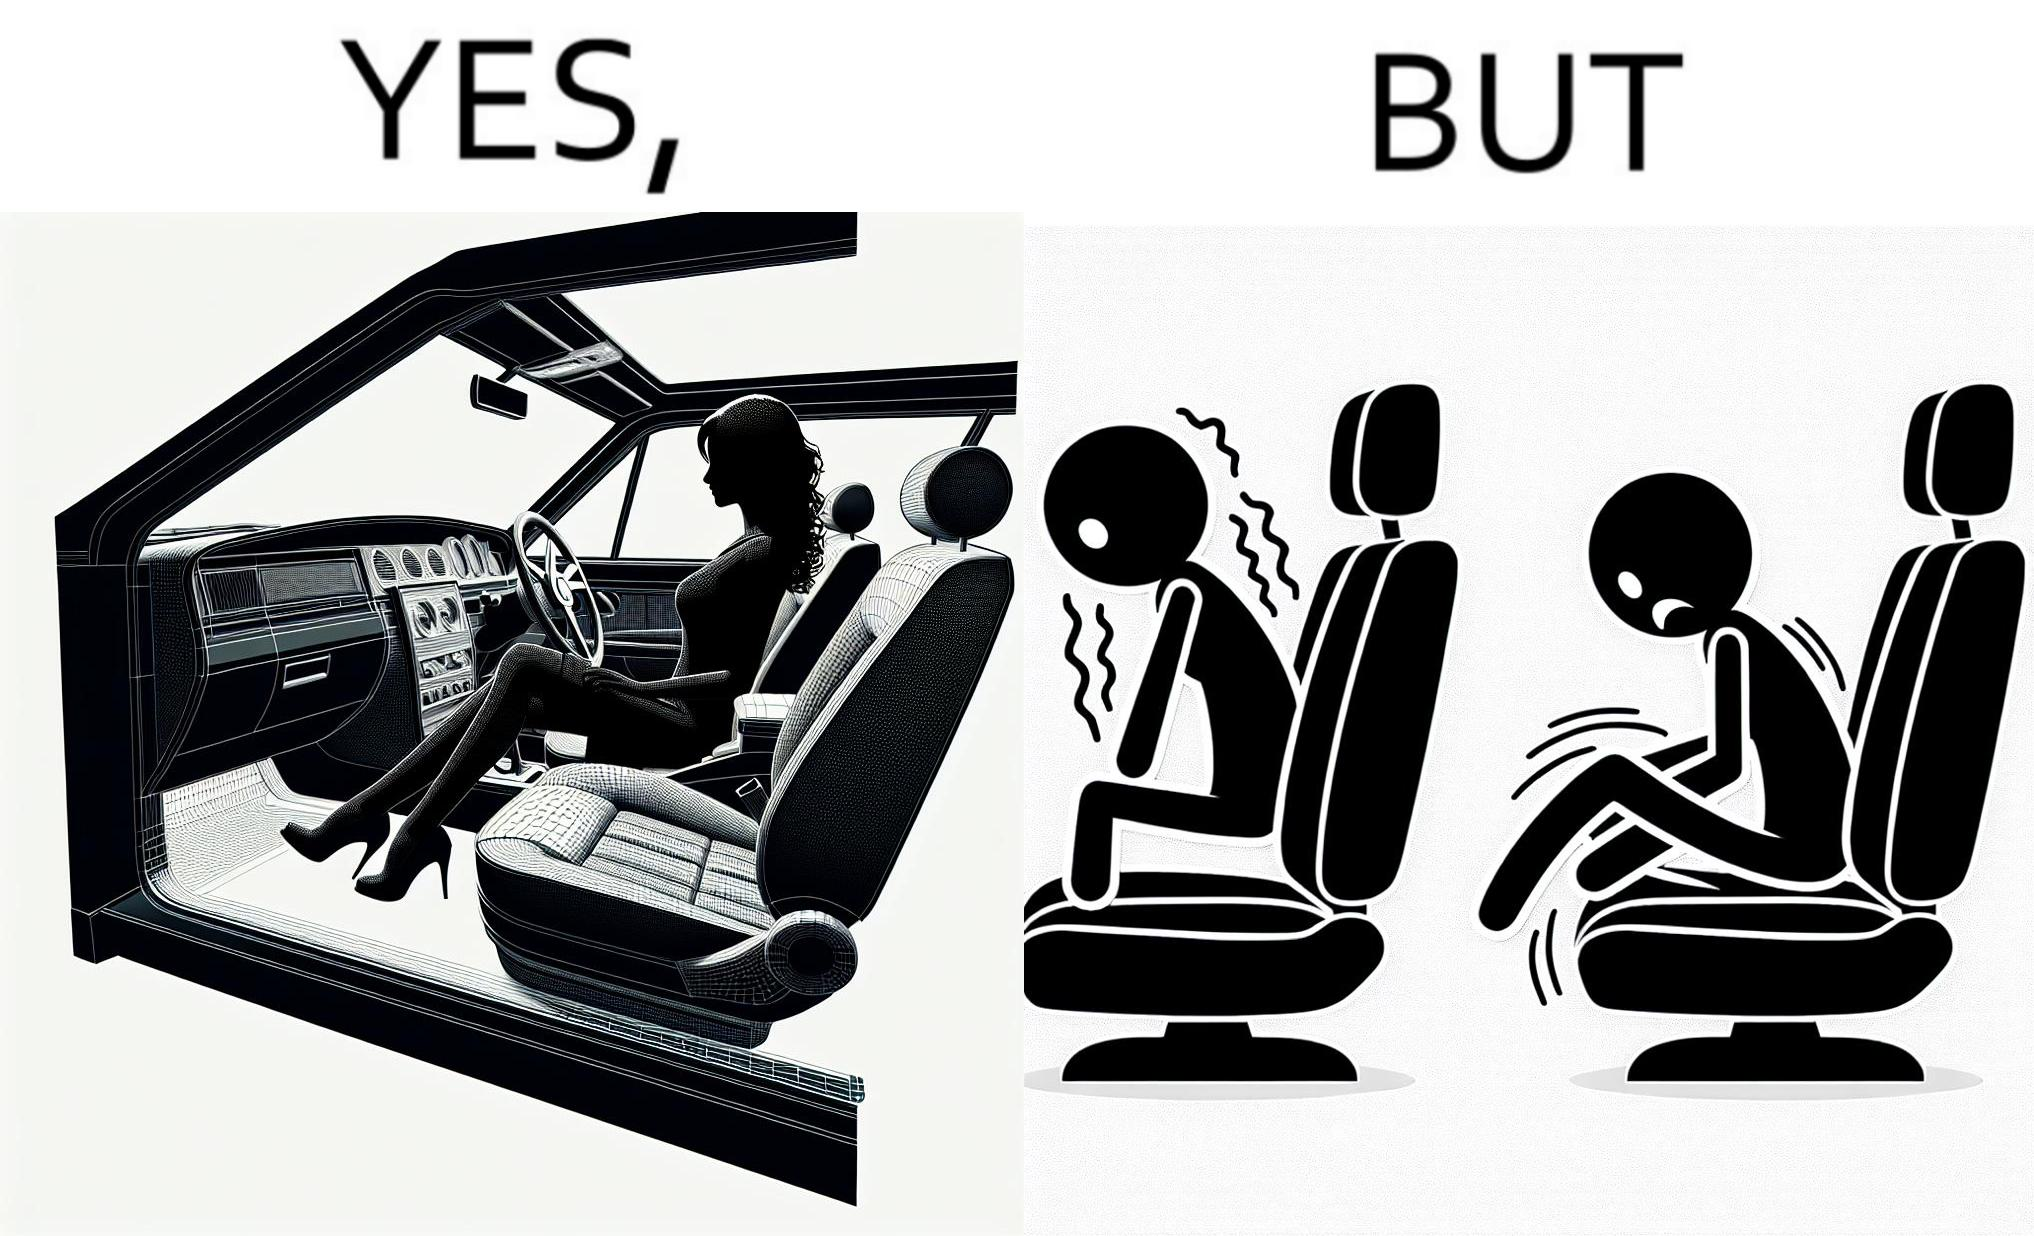What is shown in the left half versus the right half of this image? In the left part of the image: a woman wearing a short dress sitting on the co-passengers seat in a car In the right part of the image: skin of a woman getting sticked to the seat fabric of the car, causing inconvenience 